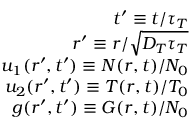Convert formula to latex. <formula><loc_0><loc_0><loc_500><loc_500>\begin{array} { r } { t ^ { \prime } \equiv t / \tau _ { T } } \\ { r ^ { \prime } \equiv r / \sqrt { D _ { T } \tau _ { T } } } \\ { u _ { 1 } ( r ^ { \prime } , t ^ { \prime } ) \equiv N ( r , t ) / N _ { 0 } } \\ { u _ { 2 } ( r ^ { \prime } , t ^ { \prime } ) \equiv T ( r , t ) / T _ { 0 } } \\ { g ( r ^ { \prime } , t ^ { \prime } ) \equiv G ( r , t ) / N _ { 0 } } \end{array}</formula> 